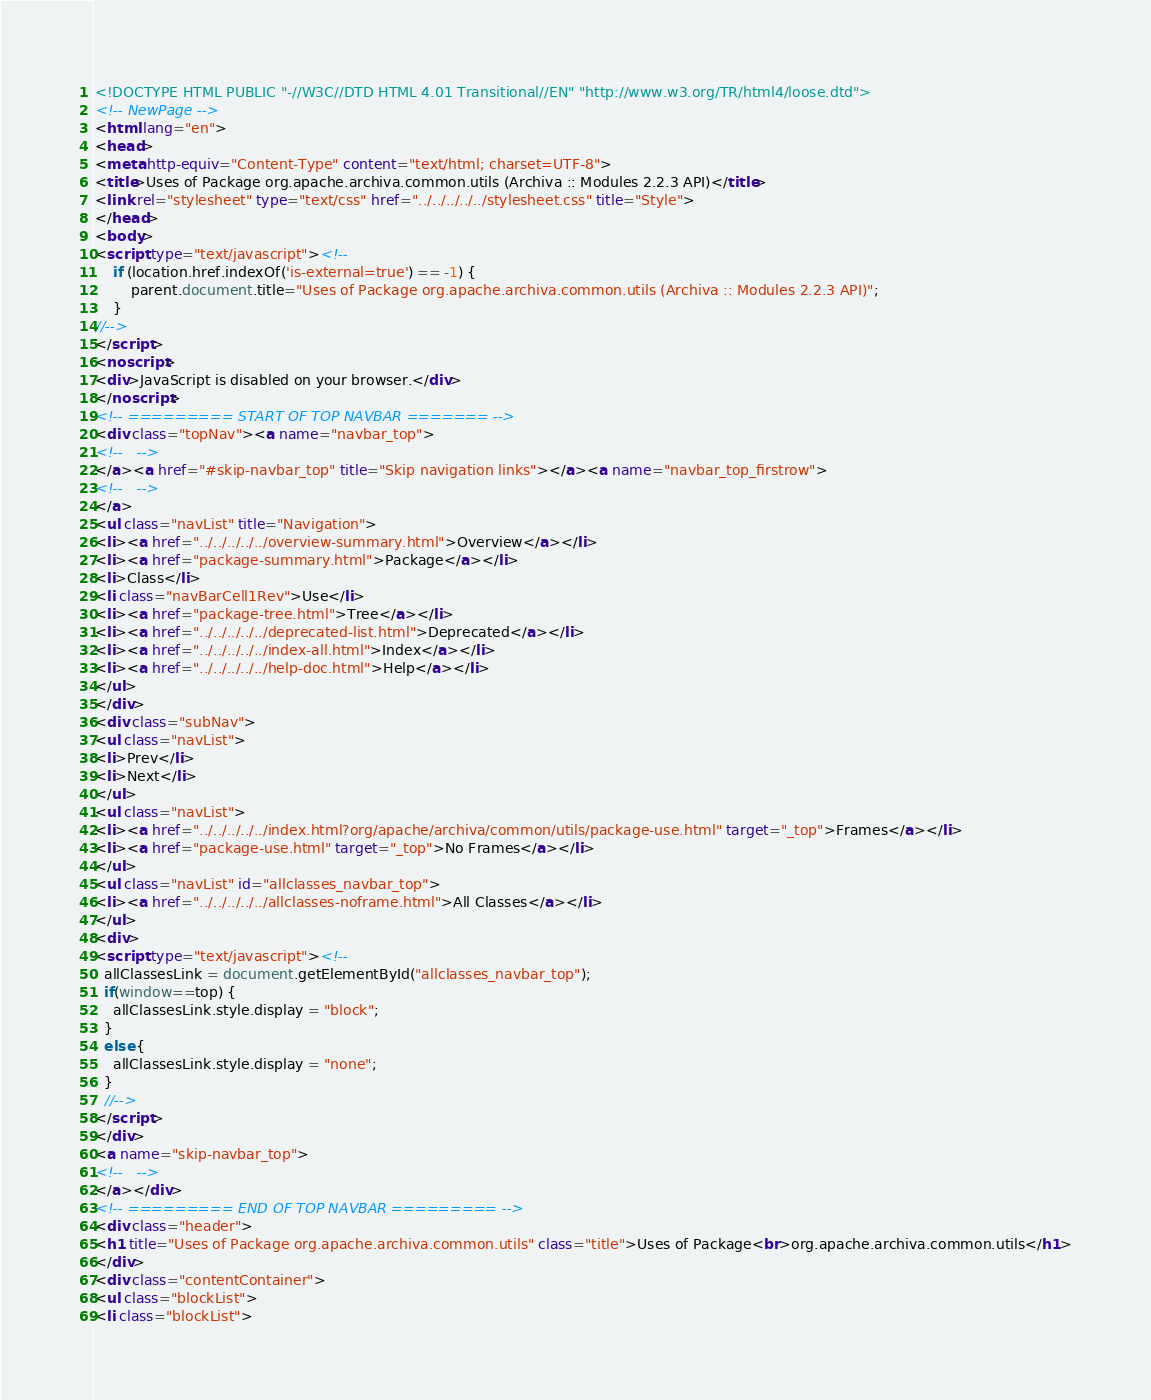<code> <loc_0><loc_0><loc_500><loc_500><_HTML_><!DOCTYPE HTML PUBLIC "-//W3C//DTD HTML 4.01 Transitional//EN" "http://www.w3.org/TR/html4/loose.dtd">
<!-- NewPage -->
<html lang="en">
<head>
<meta http-equiv="Content-Type" content="text/html; charset=UTF-8">
<title>Uses of Package org.apache.archiva.common.utils (Archiva :: Modules 2.2.3 API)</title>
<link rel="stylesheet" type="text/css" href="../../../../../stylesheet.css" title="Style">
</head>
<body>
<script type="text/javascript"><!--
    if (location.href.indexOf('is-external=true') == -1) {
        parent.document.title="Uses of Package org.apache.archiva.common.utils (Archiva :: Modules 2.2.3 API)";
    }
//-->
</script>
<noscript>
<div>JavaScript is disabled on your browser.</div>
</noscript>
<!-- ========= START OF TOP NAVBAR ======= -->
<div class="topNav"><a name="navbar_top">
<!--   -->
</a><a href="#skip-navbar_top" title="Skip navigation links"></a><a name="navbar_top_firstrow">
<!--   -->
</a>
<ul class="navList" title="Navigation">
<li><a href="../../../../../overview-summary.html">Overview</a></li>
<li><a href="package-summary.html">Package</a></li>
<li>Class</li>
<li class="navBarCell1Rev">Use</li>
<li><a href="package-tree.html">Tree</a></li>
<li><a href="../../../../../deprecated-list.html">Deprecated</a></li>
<li><a href="../../../../../index-all.html">Index</a></li>
<li><a href="../../../../../help-doc.html">Help</a></li>
</ul>
</div>
<div class="subNav">
<ul class="navList">
<li>Prev</li>
<li>Next</li>
</ul>
<ul class="navList">
<li><a href="../../../../../index.html?org/apache/archiva/common/utils/package-use.html" target="_top">Frames</a></li>
<li><a href="package-use.html" target="_top">No Frames</a></li>
</ul>
<ul class="navList" id="allclasses_navbar_top">
<li><a href="../../../../../allclasses-noframe.html">All Classes</a></li>
</ul>
<div>
<script type="text/javascript"><!--
  allClassesLink = document.getElementById("allclasses_navbar_top");
  if(window==top) {
    allClassesLink.style.display = "block";
  }
  else {
    allClassesLink.style.display = "none";
  }
  //-->
</script>
</div>
<a name="skip-navbar_top">
<!--   -->
</a></div>
<!-- ========= END OF TOP NAVBAR ========= -->
<div class="header">
<h1 title="Uses of Package org.apache.archiva.common.utils" class="title">Uses of Package<br>org.apache.archiva.common.utils</h1>
</div>
<div class="contentContainer">
<ul class="blockList">
<li class="blockList"></code> 